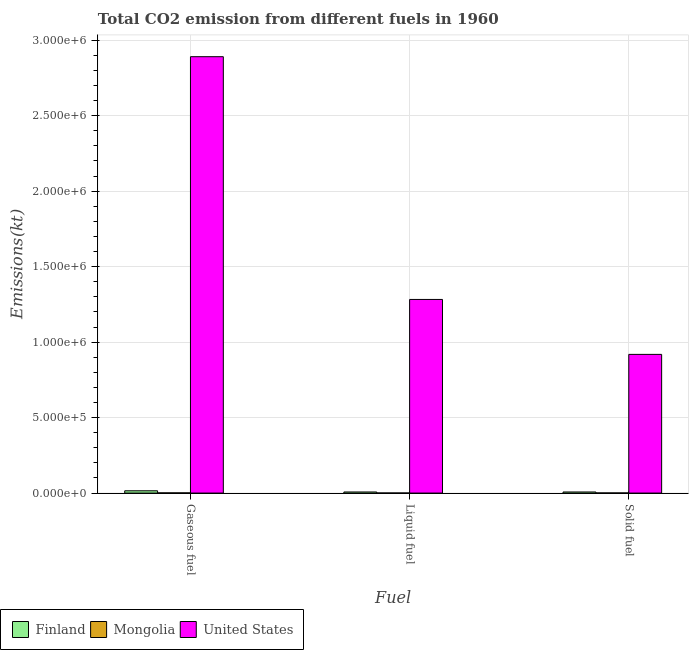How many different coloured bars are there?
Provide a short and direct response. 3. How many groups of bars are there?
Your answer should be compact. 3. What is the label of the 2nd group of bars from the left?
Your answer should be very brief. Liquid fuel. What is the amount of co2 emissions from liquid fuel in Mongolia?
Give a very brief answer. 495.05. Across all countries, what is the maximum amount of co2 emissions from liquid fuel?
Offer a terse response. 1.28e+06. Across all countries, what is the minimum amount of co2 emissions from liquid fuel?
Provide a short and direct response. 495.05. In which country was the amount of co2 emissions from gaseous fuel minimum?
Your response must be concise. Mongolia. What is the total amount of co2 emissions from gaseous fuel in the graph?
Your answer should be compact. 2.91e+06. What is the difference between the amount of co2 emissions from gaseous fuel in Finland and that in Mongolia?
Your response must be concise. 1.38e+04. What is the difference between the amount of co2 emissions from solid fuel in Mongolia and the amount of co2 emissions from liquid fuel in Finland?
Provide a short and direct response. -6409.92. What is the average amount of co2 emissions from gaseous fuel per country?
Offer a terse response. 9.69e+05. What is the difference between the amount of co2 emissions from solid fuel and amount of co2 emissions from gaseous fuel in Finland?
Keep it short and to the point. -7836.38. What is the ratio of the amount of co2 emissions from gaseous fuel in Mongolia to that in Finland?
Your answer should be very brief. 0.09. What is the difference between the highest and the second highest amount of co2 emissions from solid fuel?
Provide a short and direct response. 9.11e+05. What is the difference between the highest and the lowest amount of co2 emissions from liquid fuel?
Offer a terse response. 1.28e+06. In how many countries, is the amount of co2 emissions from liquid fuel greater than the average amount of co2 emissions from liquid fuel taken over all countries?
Your answer should be compact. 1. What is the difference between two consecutive major ticks on the Y-axis?
Provide a short and direct response. 5.00e+05. Does the graph contain any zero values?
Offer a very short reply. No. How many legend labels are there?
Your response must be concise. 3. How are the legend labels stacked?
Offer a terse response. Horizontal. What is the title of the graph?
Keep it short and to the point. Total CO2 emission from different fuels in 1960. What is the label or title of the X-axis?
Make the answer very short. Fuel. What is the label or title of the Y-axis?
Your answer should be very brief. Emissions(kt). What is the Emissions(kt) in Finland in Gaseous fuel?
Offer a very short reply. 1.51e+04. What is the Emissions(kt) in Mongolia in Gaseous fuel?
Ensure brevity in your answer.  1294.45. What is the Emissions(kt) of United States in Gaseous fuel?
Offer a very short reply. 2.89e+06. What is the Emissions(kt) in Finland in Liquid fuel?
Give a very brief answer. 7209.32. What is the Emissions(kt) in Mongolia in Liquid fuel?
Give a very brief answer. 495.05. What is the Emissions(kt) in United States in Liquid fuel?
Offer a very short reply. 1.28e+06. What is the Emissions(kt) of Finland in Solid fuel?
Provide a short and direct response. 7267.99. What is the Emissions(kt) of Mongolia in Solid fuel?
Ensure brevity in your answer.  799.41. What is the Emissions(kt) in United States in Solid fuel?
Ensure brevity in your answer.  9.19e+05. Across all Fuel, what is the maximum Emissions(kt) in Finland?
Your answer should be compact. 1.51e+04. Across all Fuel, what is the maximum Emissions(kt) in Mongolia?
Provide a succinct answer. 1294.45. Across all Fuel, what is the maximum Emissions(kt) of United States?
Give a very brief answer. 2.89e+06. Across all Fuel, what is the minimum Emissions(kt) in Finland?
Provide a succinct answer. 7209.32. Across all Fuel, what is the minimum Emissions(kt) in Mongolia?
Provide a succinct answer. 495.05. Across all Fuel, what is the minimum Emissions(kt) of United States?
Provide a succinct answer. 9.19e+05. What is the total Emissions(kt) in Finland in the graph?
Give a very brief answer. 2.96e+04. What is the total Emissions(kt) in Mongolia in the graph?
Provide a short and direct response. 2588.9. What is the total Emissions(kt) in United States in the graph?
Keep it short and to the point. 5.09e+06. What is the difference between the Emissions(kt) in Finland in Gaseous fuel and that in Liquid fuel?
Give a very brief answer. 7895.05. What is the difference between the Emissions(kt) in Mongolia in Gaseous fuel and that in Liquid fuel?
Make the answer very short. 799.41. What is the difference between the Emissions(kt) of United States in Gaseous fuel and that in Liquid fuel?
Offer a terse response. 1.61e+06. What is the difference between the Emissions(kt) of Finland in Gaseous fuel and that in Solid fuel?
Your answer should be very brief. 7836.38. What is the difference between the Emissions(kt) of Mongolia in Gaseous fuel and that in Solid fuel?
Your answer should be compact. 495.05. What is the difference between the Emissions(kt) in United States in Gaseous fuel and that in Solid fuel?
Make the answer very short. 1.97e+06. What is the difference between the Emissions(kt) of Finland in Liquid fuel and that in Solid fuel?
Ensure brevity in your answer.  -58.67. What is the difference between the Emissions(kt) in Mongolia in Liquid fuel and that in Solid fuel?
Provide a succinct answer. -304.36. What is the difference between the Emissions(kt) of United States in Liquid fuel and that in Solid fuel?
Ensure brevity in your answer.  3.64e+05. What is the difference between the Emissions(kt) of Finland in Gaseous fuel and the Emissions(kt) of Mongolia in Liquid fuel?
Your answer should be very brief. 1.46e+04. What is the difference between the Emissions(kt) in Finland in Gaseous fuel and the Emissions(kt) in United States in Liquid fuel?
Your answer should be very brief. -1.27e+06. What is the difference between the Emissions(kt) in Mongolia in Gaseous fuel and the Emissions(kt) in United States in Liquid fuel?
Provide a short and direct response. -1.28e+06. What is the difference between the Emissions(kt) in Finland in Gaseous fuel and the Emissions(kt) in Mongolia in Solid fuel?
Provide a succinct answer. 1.43e+04. What is the difference between the Emissions(kt) in Finland in Gaseous fuel and the Emissions(kt) in United States in Solid fuel?
Your response must be concise. -9.04e+05. What is the difference between the Emissions(kt) of Mongolia in Gaseous fuel and the Emissions(kt) of United States in Solid fuel?
Make the answer very short. -9.17e+05. What is the difference between the Emissions(kt) in Finland in Liquid fuel and the Emissions(kt) in Mongolia in Solid fuel?
Give a very brief answer. 6409.92. What is the difference between the Emissions(kt) in Finland in Liquid fuel and the Emissions(kt) in United States in Solid fuel?
Offer a terse response. -9.12e+05. What is the difference between the Emissions(kt) of Mongolia in Liquid fuel and the Emissions(kt) of United States in Solid fuel?
Give a very brief answer. -9.18e+05. What is the average Emissions(kt) of Finland per Fuel?
Ensure brevity in your answer.  9860.56. What is the average Emissions(kt) in Mongolia per Fuel?
Make the answer very short. 862.97. What is the average Emissions(kt) of United States per Fuel?
Ensure brevity in your answer.  1.70e+06. What is the difference between the Emissions(kt) of Finland and Emissions(kt) of Mongolia in Gaseous fuel?
Your answer should be very brief. 1.38e+04. What is the difference between the Emissions(kt) in Finland and Emissions(kt) in United States in Gaseous fuel?
Your answer should be compact. -2.88e+06. What is the difference between the Emissions(kt) of Mongolia and Emissions(kt) of United States in Gaseous fuel?
Your answer should be compact. -2.89e+06. What is the difference between the Emissions(kt) in Finland and Emissions(kt) in Mongolia in Liquid fuel?
Offer a terse response. 6714.28. What is the difference between the Emissions(kt) in Finland and Emissions(kt) in United States in Liquid fuel?
Ensure brevity in your answer.  -1.28e+06. What is the difference between the Emissions(kt) of Mongolia and Emissions(kt) of United States in Liquid fuel?
Keep it short and to the point. -1.28e+06. What is the difference between the Emissions(kt) in Finland and Emissions(kt) in Mongolia in Solid fuel?
Give a very brief answer. 6468.59. What is the difference between the Emissions(kt) of Finland and Emissions(kt) of United States in Solid fuel?
Offer a very short reply. -9.11e+05. What is the difference between the Emissions(kt) in Mongolia and Emissions(kt) in United States in Solid fuel?
Offer a terse response. -9.18e+05. What is the ratio of the Emissions(kt) of Finland in Gaseous fuel to that in Liquid fuel?
Provide a succinct answer. 2.1. What is the ratio of the Emissions(kt) of Mongolia in Gaseous fuel to that in Liquid fuel?
Offer a very short reply. 2.61. What is the ratio of the Emissions(kt) in United States in Gaseous fuel to that in Liquid fuel?
Ensure brevity in your answer.  2.25. What is the ratio of the Emissions(kt) of Finland in Gaseous fuel to that in Solid fuel?
Give a very brief answer. 2.08. What is the ratio of the Emissions(kt) in Mongolia in Gaseous fuel to that in Solid fuel?
Provide a short and direct response. 1.62. What is the ratio of the Emissions(kt) in United States in Gaseous fuel to that in Solid fuel?
Your answer should be very brief. 3.15. What is the ratio of the Emissions(kt) of Mongolia in Liquid fuel to that in Solid fuel?
Provide a short and direct response. 0.62. What is the ratio of the Emissions(kt) of United States in Liquid fuel to that in Solid fuel?
Keep it short and to the point. 1.4. What is the difference between the highest and the second highest Emissions(kt) of Finland?
Keep it short and to the point. 7836.38. What is the difference between the highest and the second highest Emissions(kt) in Mongolia?
Your answer should be very brief. 495.05. What is the difference between the highest and the second highest Emissions(kt) in United States?
Provide a succinct answer. 1.61e+06. What is the difference between the highest and the lowest Emissions(kt) in Finland?
Keep it short and to the point. 7895.05. What is the difference between the highest and the lowest Emissions(kt) in Mongolia?
Ensure brevity in your answer.  799.41. What is the difference between the highest and the lowest Emissions(kt) of United States?
Your answer should be compact. 1.97e+06. 